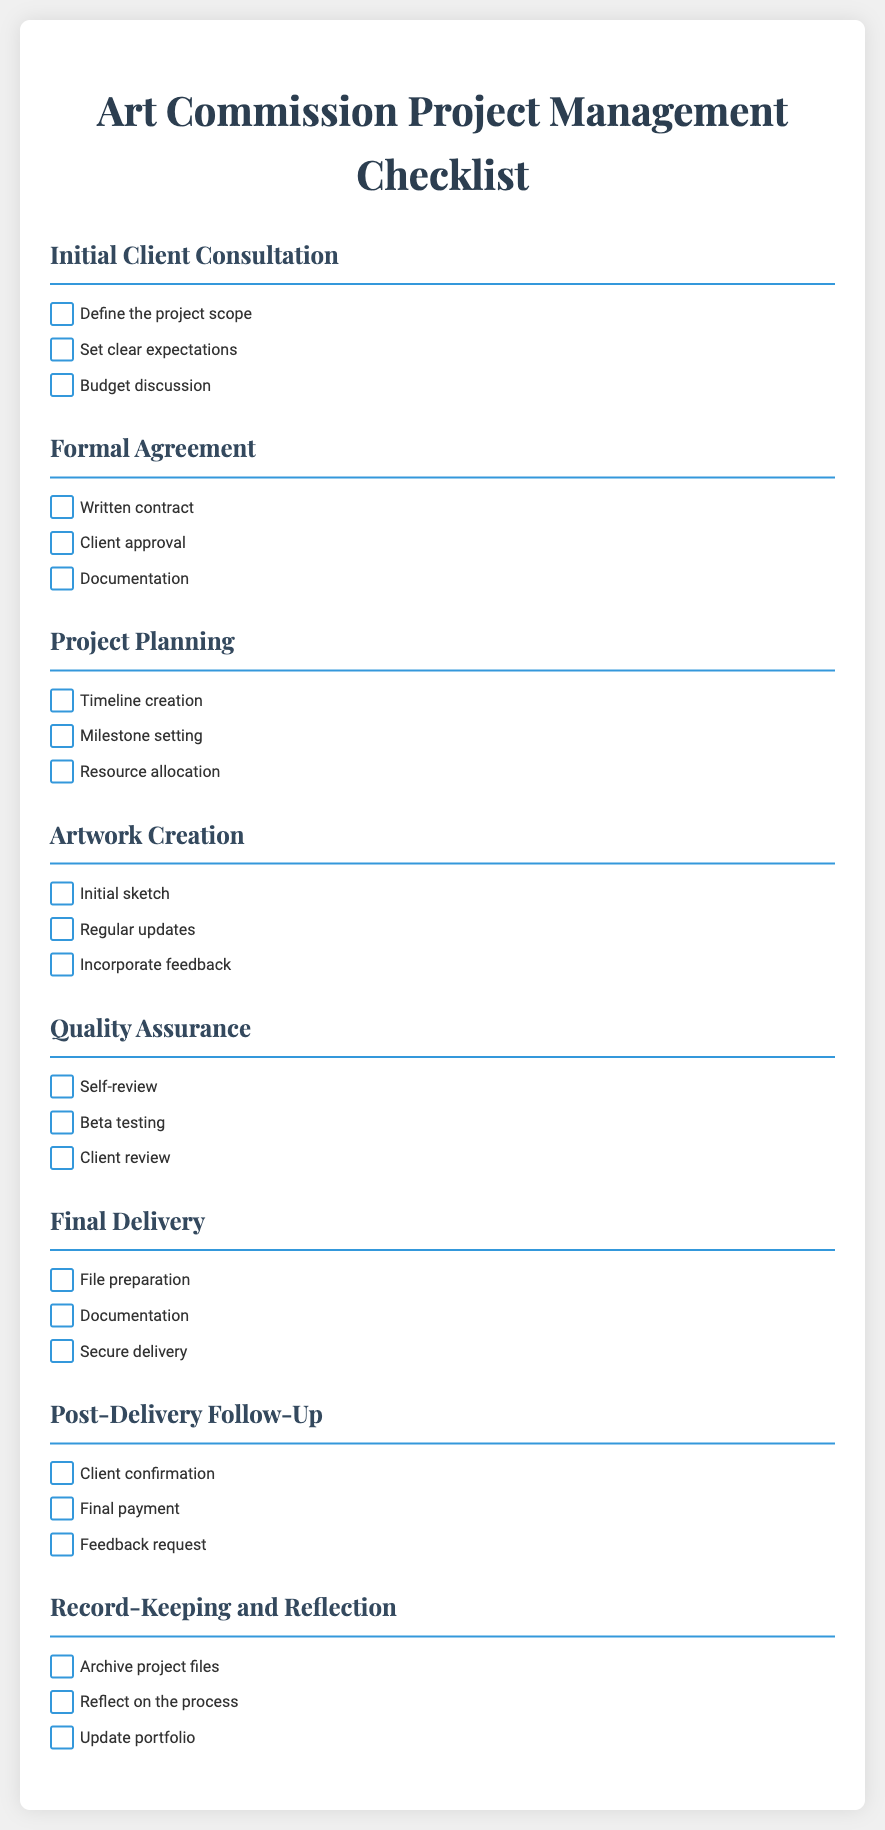What are the steps in the Initial Client Consultation? The steps include defining the project scope, setting clear expectations, and discussing the budget.
Answer: Define the project scope, set clear expectations, budget discussion What should be included in the Formal Agreement? The formal agreement should include a written contract, client approval, and documentation.
Answer: Written contract, client approval, documentation How many sections are in the checklist? The checklist includes seven sections focusing on various aspects of the project management process.
Answer: Seven What is the primary focus of the Quality Assurance section? This section emphasizes self-review, beta testing, and client review to ensure the artwork meets the expected standards.
Answer: Self-review, beta testing, client review What is one task in the Final Delivery section? One of the tasks is to prepare the final files for delivery to the client.
Answer: File preparation What is the last section of the checklist? The final section pertains to record-keeping and reflection on the project after delivery.
Answer: Record-Keeping and Reflection 